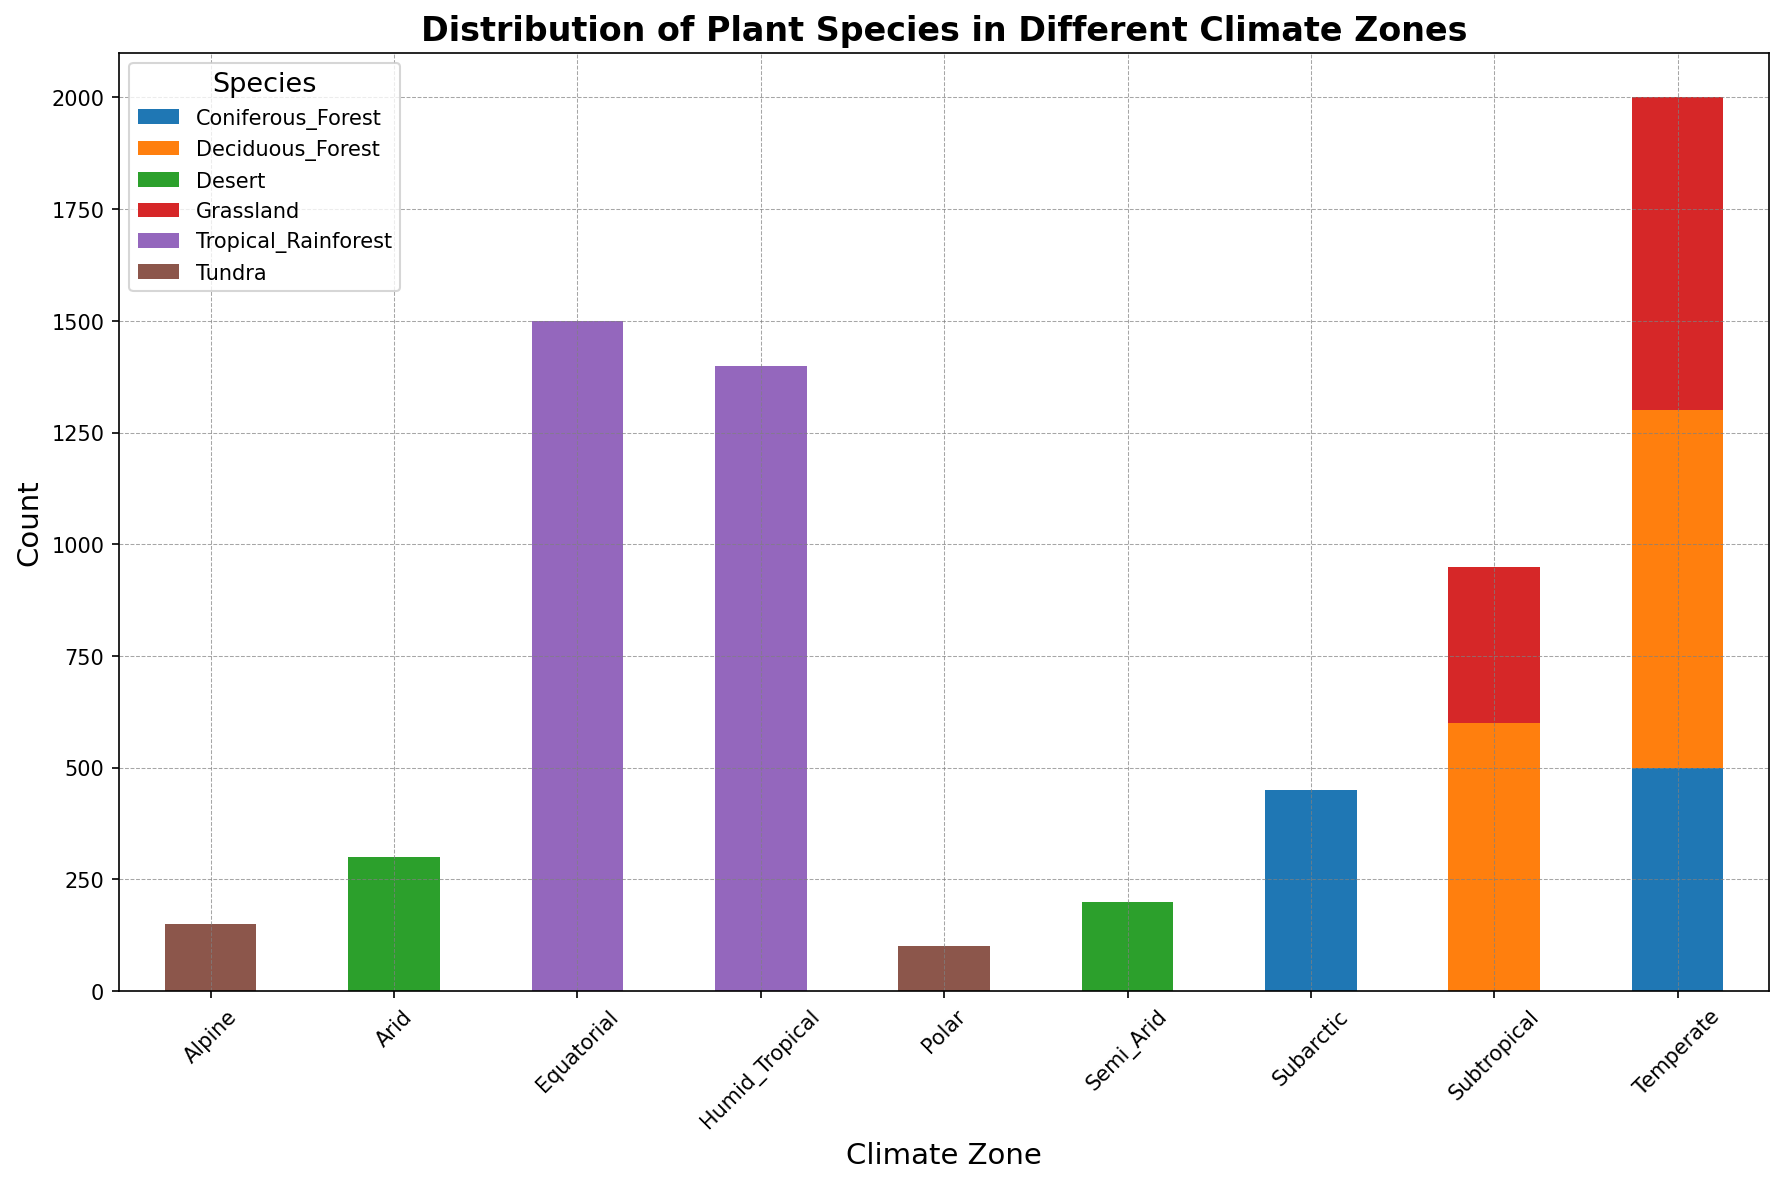Which climate zone has the highest count of Tropical Rainforest species? In the bar chart, look for the bar corresponding to the Tropical Rainforest species and compare the heights across different climate zones. The Equatorial climate zone has the highest bar for Tropical Rainforest.
Answer: Equatorial Which species has the least count in the Polar climate zone? Identify the bar corresponding to the Polar climate zone and compare the heights of all species in that zone. The Tundra species has the lowest bar height in the Polar climate zone.
Answer: Tundra What is the total count of Deciduous Forest species in all climate zones? Find the bars corresponding to Deciduous Forest species across all climate zones and sum their heights. Deciduous Forest has 800+600=1400 in Temperate and Subtropical climate zones respectively.
Answer: 1400 Which climate zone has more Grassland species, Temperate or Subtropical? Compare the heights of Grassland bars in Temperate and Subtropical climate zones. The Grassland bar is higher in the Temperate climate zone (700) than in Subtropical (350).
Answer: Temperate Are there more Coniferous Forest species in the Subarctic or Temperate climate zone? Check the bar heights for Coniferous Forest species in Subarctic and Temperate climate zones. The Temperate climate zone has a higher bar (500) compared to Subarctic (450).
Answer: Temperate What is the difference in the count of Desert species between Arid and Semi-Arid climate zones? Subtract the bar height of Desert species in the Semi-Arid climate zone from the height in the Arid climate zone. The counts are 300 for Arid and 200 for Semi-Arid, so 300 - 200 = 100.
Answer: 100 Which species has a higher count in the Humid Tropical climate zone: Tropical Rainforest or any other species? Identify the bars in the Humid Tropical climate zone and compare the height of the Tropical Rainforest bar with other species. The Tropical Rainforest bar is significantly higher (1400) than any other species.
Answer: Tropical Rainforest What is the average count of species in the Subtropical climate zone? Sum all the bar heights in the Subtropical climate zone and divide by the number of species. The Subtropical species counts are 600 (Deciduous Forest) + 350 (Grassland) = 950. Dividing by the number of species (2), the average is 950/2 = 475.
Answer: 475 Which climate zone has the highest overall plant species count? Sum the heights of all bars in each climate zone and compare the totals. The Equatorial climate zone has the highest overall species count.
Answer: Equatorial Are there more Tundra species in the Alpine or Polar climate zone? Compare the bar heights for Tundra species in the Alpine and Polar climate zones. The Alpine zone has a slightly higher bar (150) compared to the Polar (100).
Answer: Alpine 